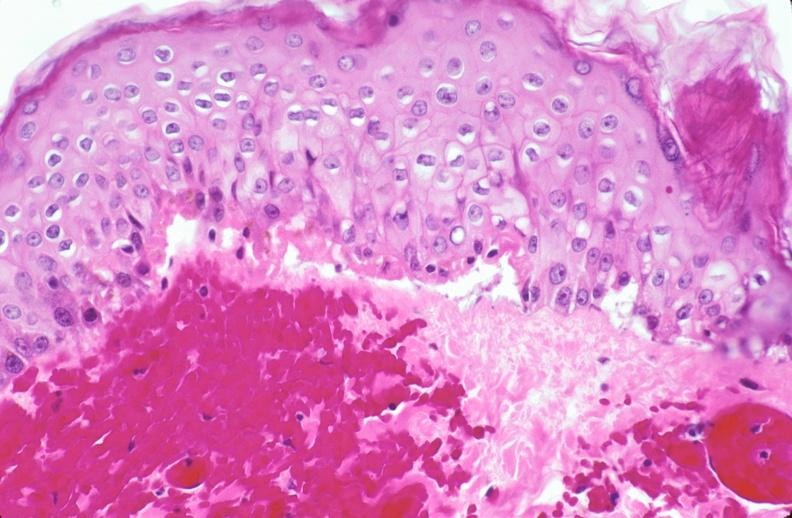does fibrous meningioma show skin, epidermolysis bullosa?
Answer the question using a single word or phrase. No 